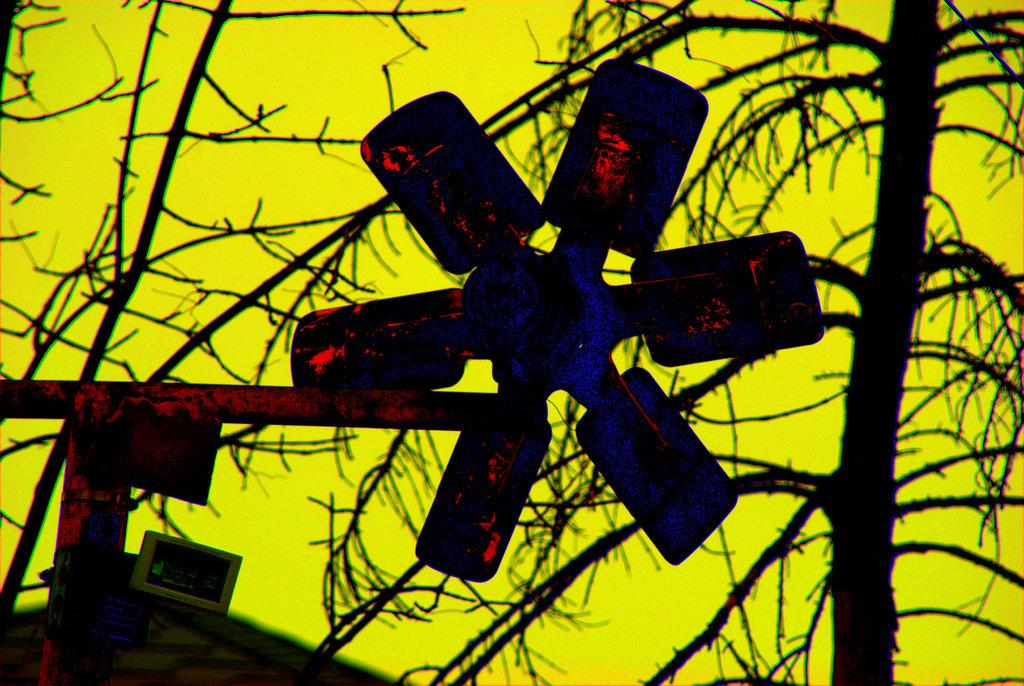What object is located in the middle of the image? There is a fan in the middle of the image. What type of tree can be seen on the right side of the image? There is a dry tree on the right side of the image. What is visible in the background of the image? The sky is visible in the background of the image. What color is the sky in the image? The sky has a yellow color in the image. How many girls are participating in the trip shown in the image? There is no trip or girls present in the image. What unit of measurement is used to determine the size of the fan in the image? The image does not provide any information about the size of the fan or the unit of measurement used. 